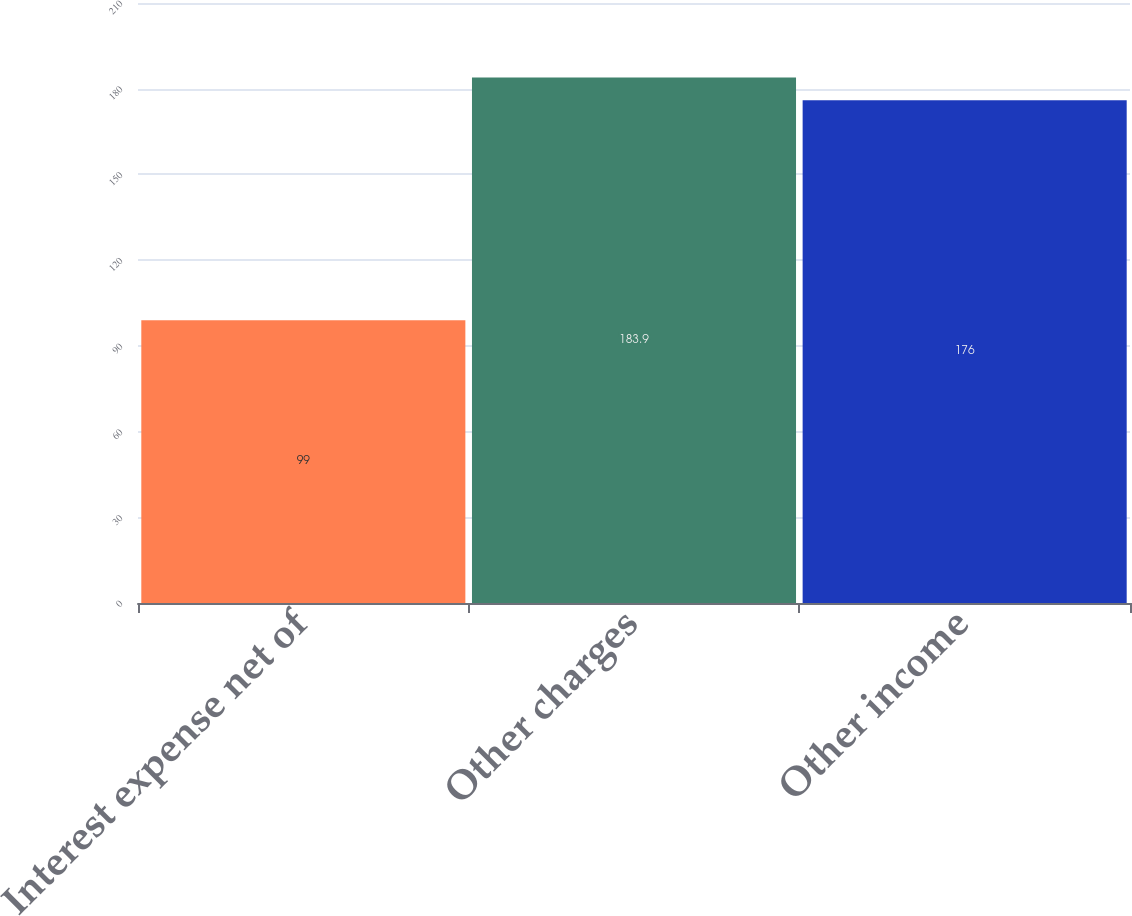Convert chart to OTSL. <chart><loc_0><loc_0><loc_500><loc_500><bar_chart><fcel>Interest expense net of<fcel>Other charges<fcel>Other income<nl><fcel>99<fcel>183.9<fcel>176<nl></chart> 